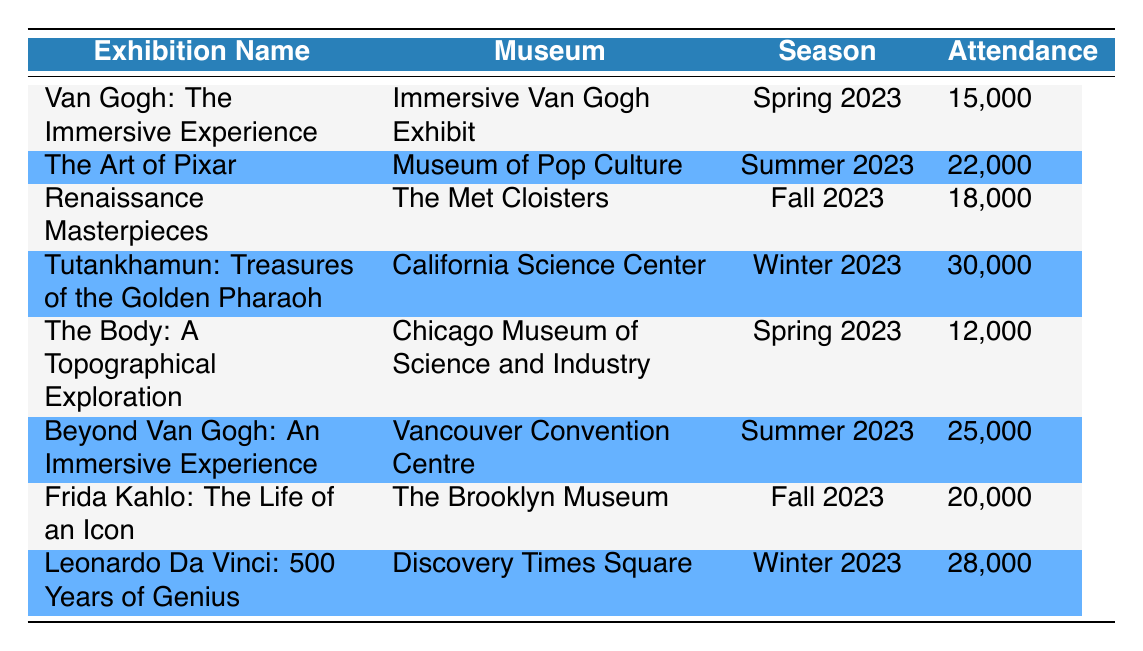What is the attendance for the exhibition "The Art of Pixar"? The table shows that "The Art of Pixar" had an attendance of 22,000.
Answer: 22,000 Which museum hosted the exhibition "Tutankhamun: Treasures of the Golden Pharaoh"? According to the table, the exhibition "Tutankhamun: Treasures of the Golden Pharaoh" was hosted by the California Science Center.
Answer: California Science Center What is the total attendance for exhibitions held in Spring 2023? The total attendance for Spring 2023 can be calculated by adding the attendance of the two exhibitions: 15,000 (Van Gogh: The Immersive Experience) + 12,000 (The Body: A Topographical Exploration) = 27,000.
Answer: 27,000 Is the attendance for "Frida Kahlo: The Life of an Icon" higher than 18,000? The table indicates that "Frida Kahlo: The Life of an Icon" had an attendance of 20,000, which is indeed higher than 18,000.
Answer: Yes What is the difference in attendance between the highest and lowest exhibitions? To find the difference, we take the highest attendance (30,000 for Tutankhamun: Treasures of the Golden Pharaoh) and subtract the lowest attendance (12,000 for The Body: A Topographical Exploration): 30,000 - 12,000 = 18,000.
Answer: 18,000 